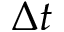<formula> <loc_0><loc_0><loc_500><loc_500>\Delta t</formula> 